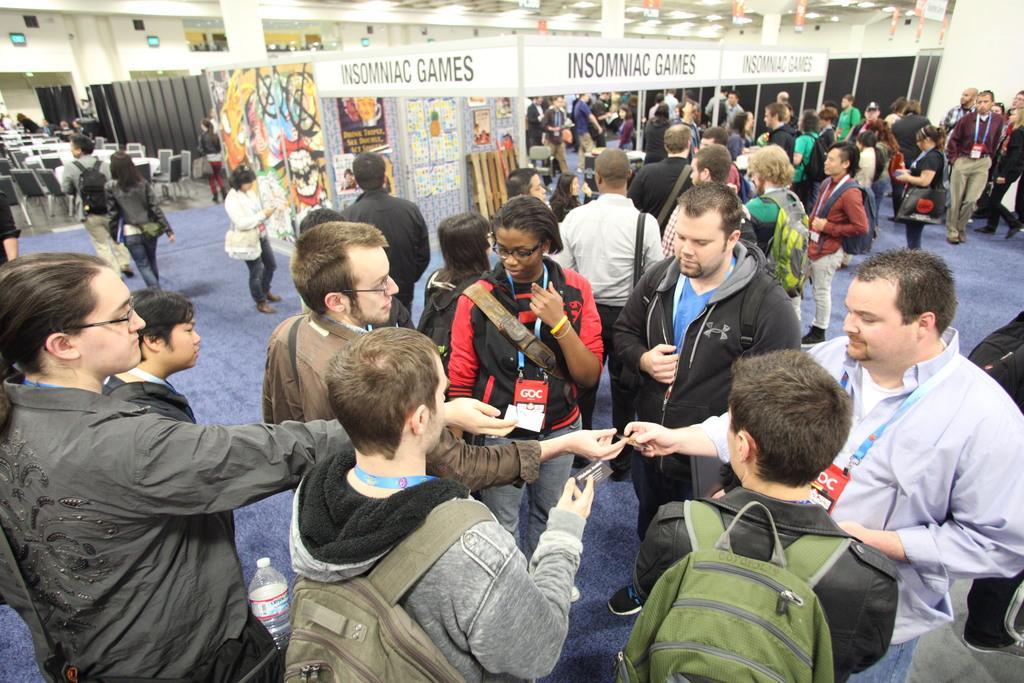Can you describe this image briefly? This picture describes about group of people, few are standing and few are walking, in this we can find few people wore backpacks, in the background we can see chairs, lights and paintings. 